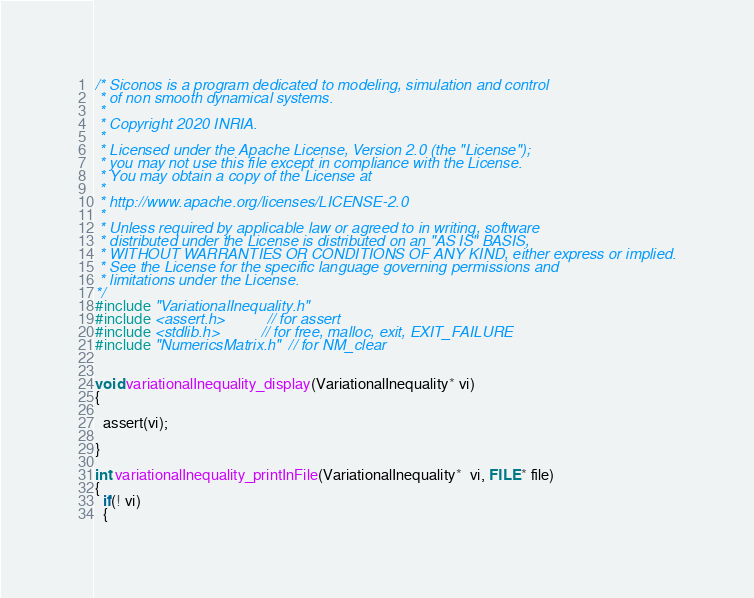Convert code to text. <code><loc_0><loc_0><loc_500><loc_500><_C_>/* Siconos is a program dedicated to modeling, simulation and control
 * of non smooth dynamical systems.
 *
 * Copyright 2020 INRIA.
 *
 * Licensed under the Apache License, Version 2.0 (the "License");
 * you may not use this file except in compliance with the License.
 * You may obtain a copy of the License at
 *
 * http://www.apache.org/licenses/LICENSE-2.0
 *
 * Unless required by applicable law or agreed to in writing, software
 * distributed under the License is distributed on an "AS IS" BASIS,
 * WITHOUT WARRANTIES OR CONDITIONS OF ANY KIND, either express or implied.
 * See the License for the specific language governing permissions and
 * limitations under the License.
*/
#include "VariationalInequality.h"
#include <assert.h>          // for assert
#include <stdlib.h>          // for free, malloc, exit, EXIT_FAILURE
#include "NumericsMatrix.h"  // for NM_clear


void variationalInequality_display(VariationalInequality* vi)
{

  assert(vi);

}

int variationalInequality_printInFile(VariationalInequality*  vi, FILE* file)
{
  if(! vi)
  {</code> 